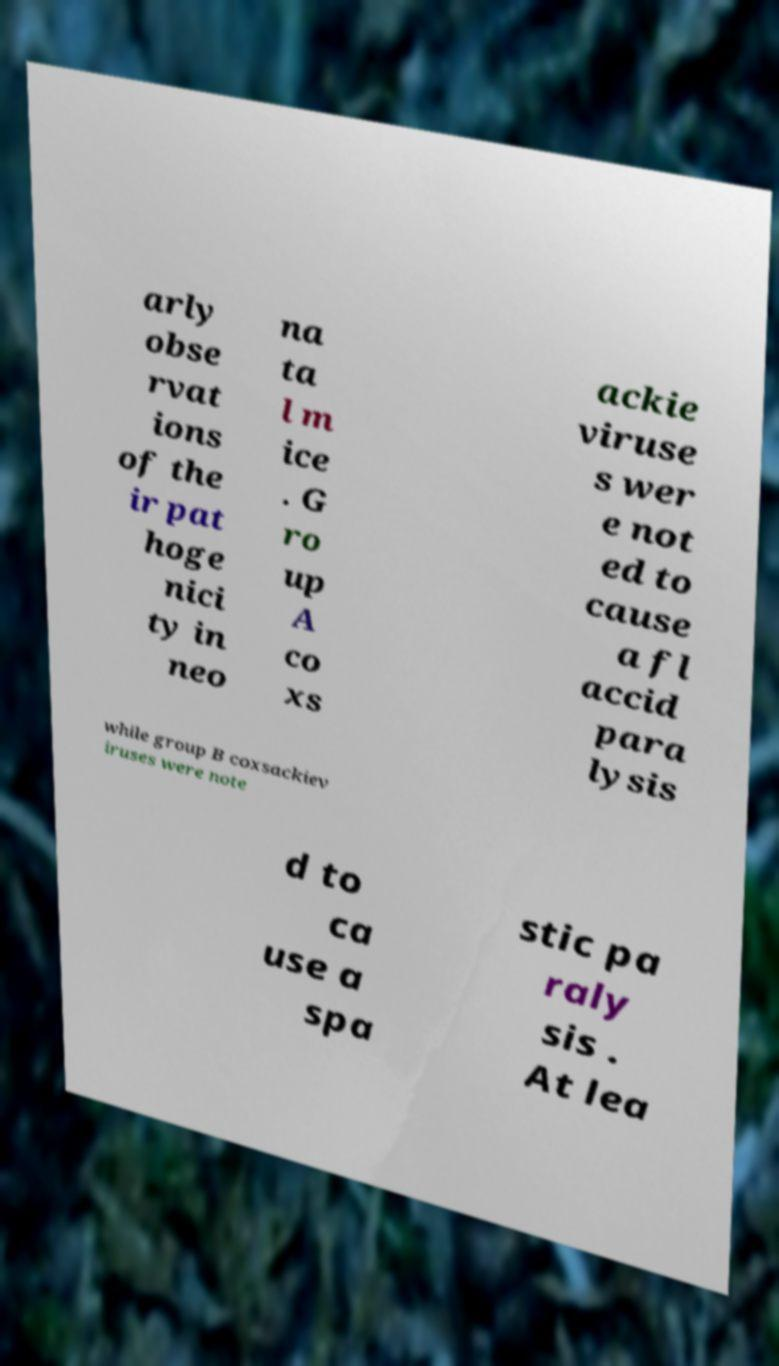Can you accurately transcribe the text from the provided image for me? arly obse rvat ions of the ir pat hoge nici ty in neo na ta l m ice . G ro up A co xs ackie viruse s wer e not ed to cause a fl accid para lysis while group B coxsackiev iruses were note d to ca use a spa stic pa raly sis . At lea 